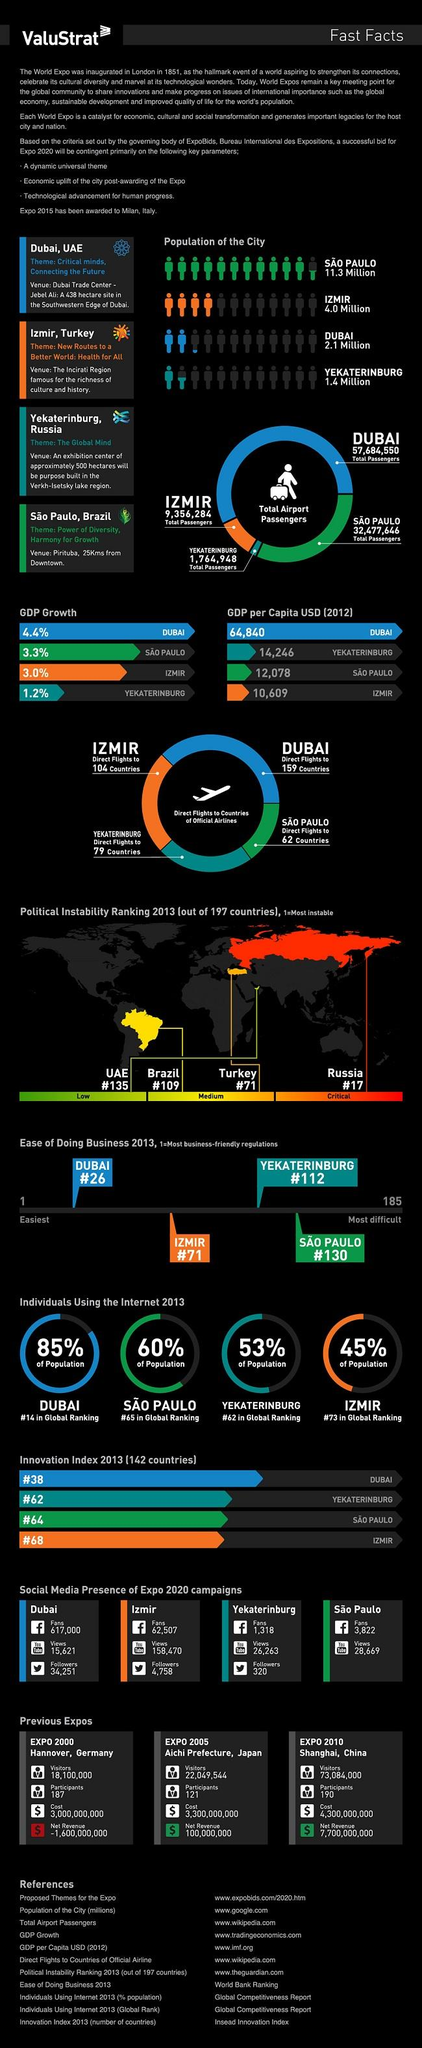Mention a couple of crucial points in this snapshot. The political instability ranking of Russia in 2013 was 17. The population of Izmir City is approximately 4.0 million. Dubai is the country with the highest total number of air passengers. Yekaterinburg, a country, has the lowest total number of air passengers. The population of Sao Paulo City is estimated to be approximately 11.3 million. 